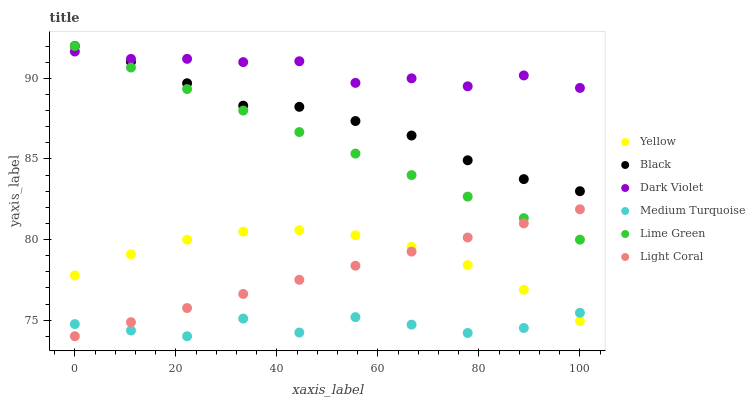Does Medium Turquoise have the minimum area under the curve?
Answer yes or no. Yes. Does Dark Violet have the maximum area under the curve?
Answer yes or no. Yes. Does Light Coral have the minimum area under the curve?
Answer yes or no. No. Does Light Coral have the maximum area under the curve?
Answer yes or no. No. Is Light Coral the smoothest?
Answer yes or no. Yes. Is Medium Turquoise the roughest?
Answer yes or no. Yes. Is Black the smoothest?
Answer yes or no. No. Is Black the roughest?
Answer yes or no. No. Does Light Coral have the lowest value?
Answer yes or no. Yes. Does Black have the lowest value?
Answer yes or no. No. Does Lime Green have the highest value?
Answer yes or no. Yes. Does Light Coral have the highest value?
Answer yes or no. No. Is Yellow less than Dark Violet?
Answer yes or no. Yes. Is Dark Violet greater than Yellow?
Answer yes or no. Yes. Does Black intersect Dark Violet?
Answer yes or no. Yes. Is Black less than Dark Violet?
Answer yes or no. No. Is Black greater than Dark Violet?
Answer yes or no. No. Does Yellow intersect Dark Violet?
Answer yes or no. No. 